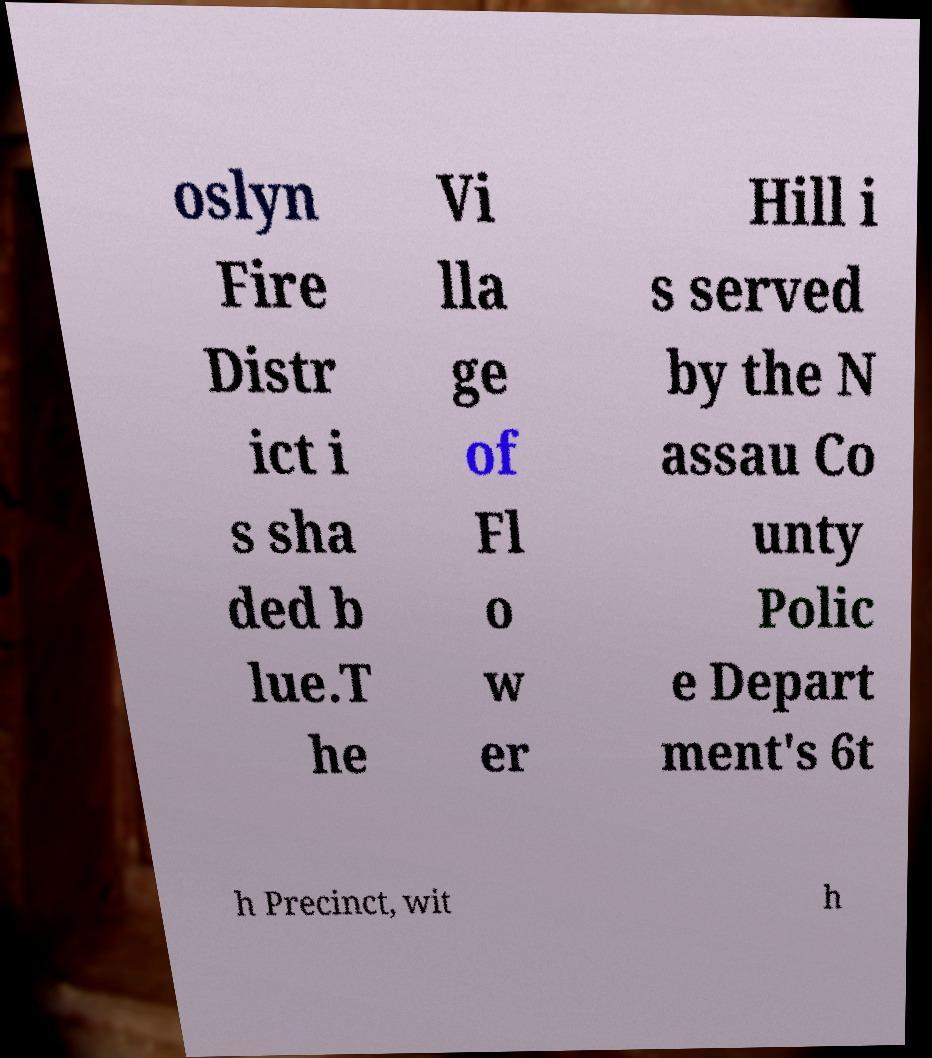There's text embedded in this image that I need extracted. Can you transcribe it verbatim? oslyn Fire Distr ict i s sha ded b lue.T he Vi lla ge of Fl o w er Hill i s served by the N assau Co unty Polic e Depart ment's 6t h Precinct, wit h 